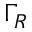<formula> <loc_0><loc_0><loc_500><loc_500>\Gamma _ { R }</formula> 